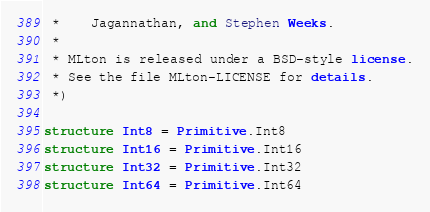<code> <loc_0><loc_0><loc_500><loc_500><_SML_> *    Jagannathan, and Stephen Weeks.
 *
 * MLton is released under a BSD-style license.
 * See the file MLton-LICENSE for details.
 *)

structure Int8 = Primitive.Int8
structure Int16 = Primitive.Int16
structure Int32 = Primitive.Int32
structure Int64 = Primitive.Int64
</code> 